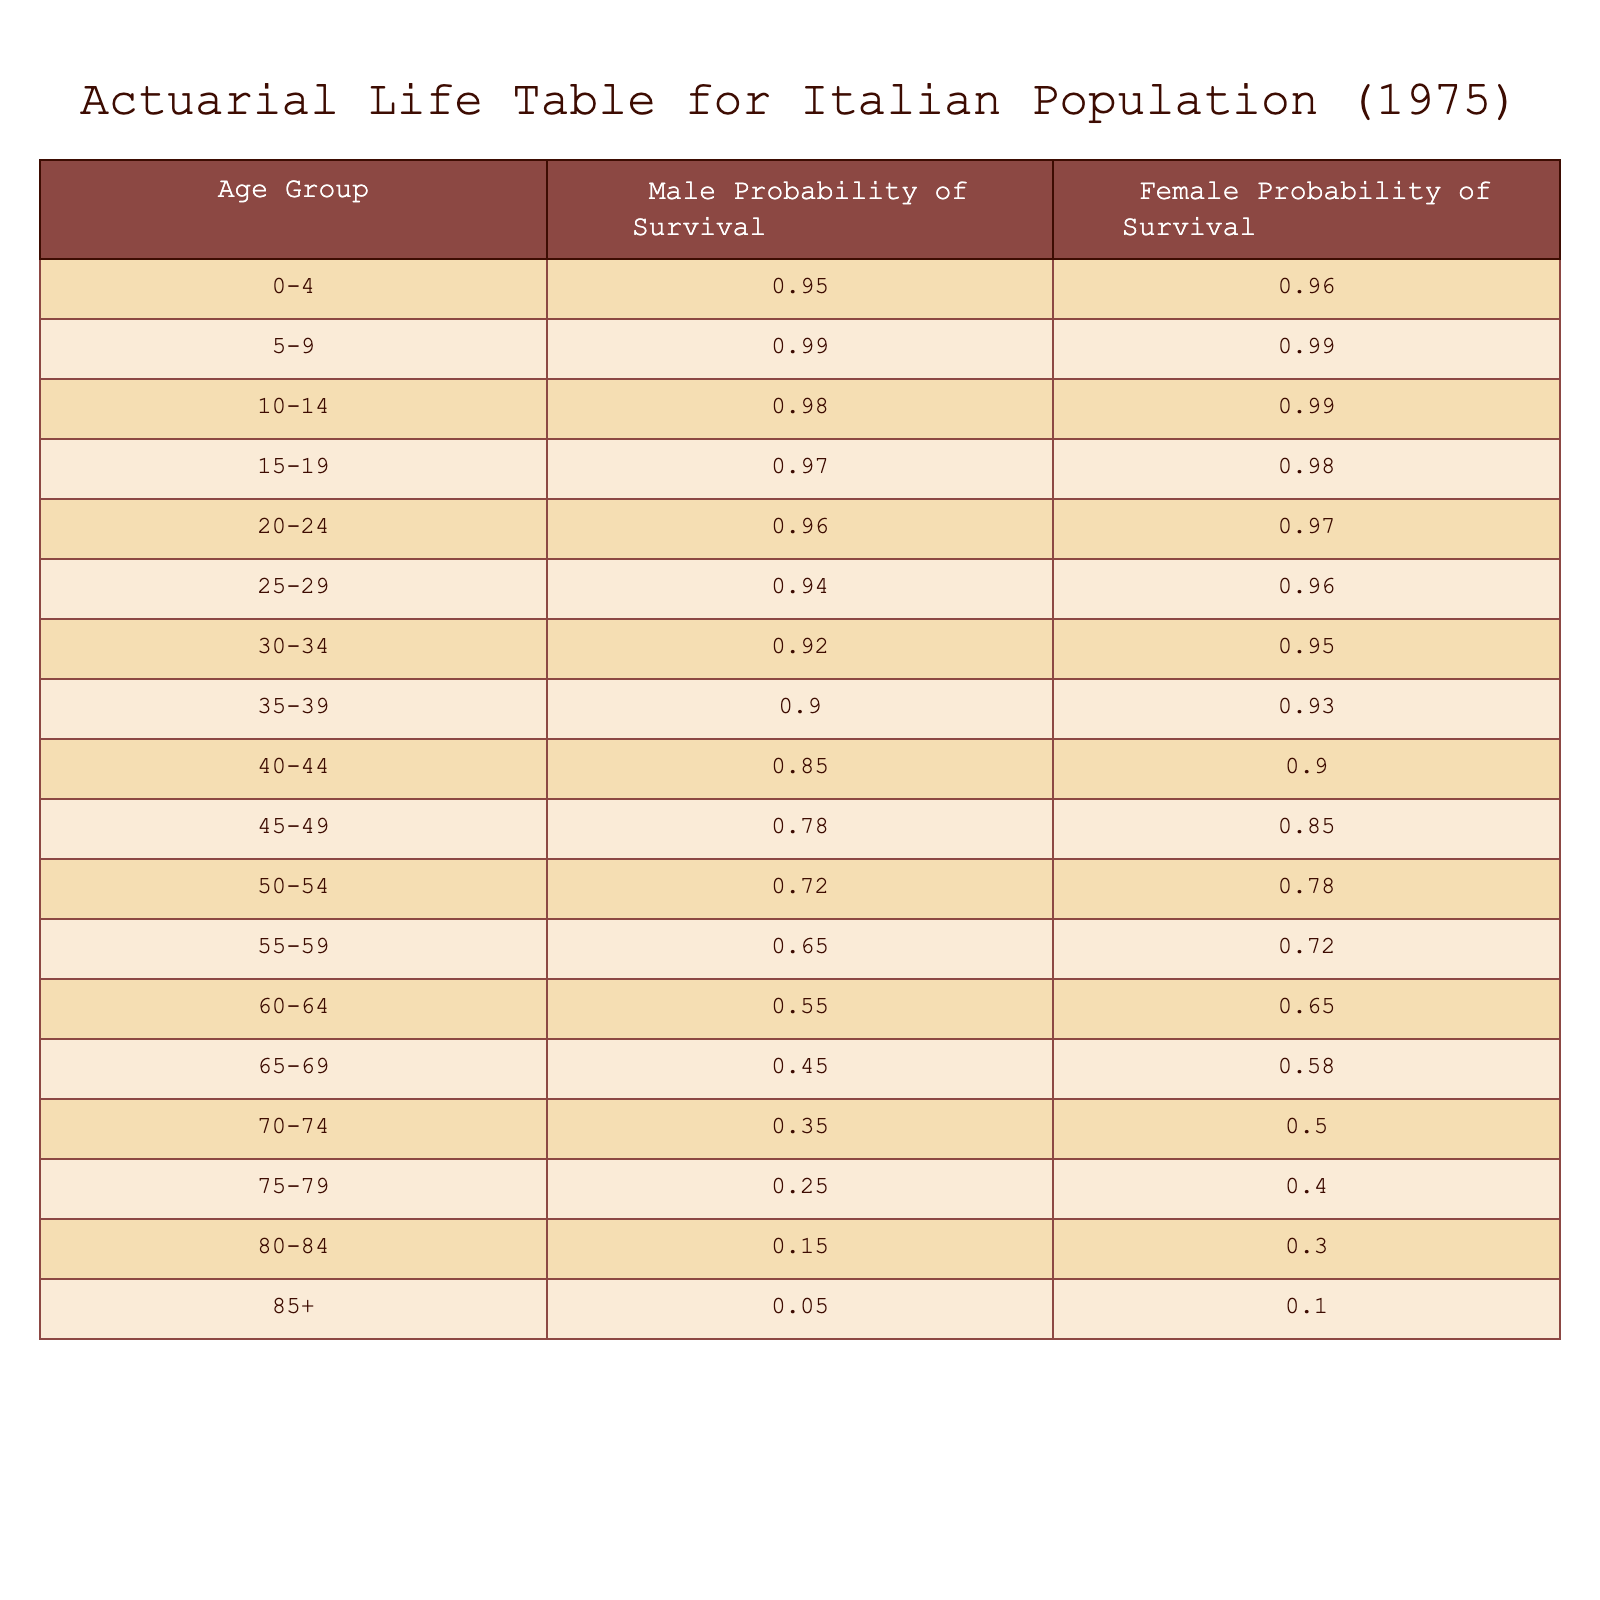What is the probability of survival for males aged 30-34? According to the table, the probability of survival for males aged 30-34 is directly listed as 0.92.
Answer: 0.92 What is the probability of survival for females in the age group 70-74? In the table, the probability of survival for females aged 70-74 is found to be 0.50.
Answer: 0.50 Which age group shows the lowest probability of survival for males? By examining the table, the lowest probability for males comes from the age group 80-84, which is 0.15.
Answer: 0.15 On average, how does female survival probability compare between the age groups 55-59 and 60-64? For females aged 55-59, the survival probability is 0.72; for 60-64, it is 0.65. The average of these two values is (0.72 + 0.65) / 2 = 0.685.
Answer: 0.685 Is the probability of survival greater for females in the age group 45-49 than for males in the same group? Looking at the probabilities, females aged 45-49 have a survival probability of 0.85, while males in the same group have a probability of 0.78. This means females have a higher probability.
Answer: Yes What is the total probability of survival for males across the age groups 0-4 and 5-9? The survival probabilities for males in these groups are 0.95 (0-4) and 0.99 (5-9). Adding these together gives 0.95 + 0.99 = 1.94.
Answer: 1.94 If we compare the probabilities of survival for the age group 75-79, do males or females have a higher survival rate? In the table, males aged 75-79 have a survival probability of 0.25, whereas females in the same age group have 0.40. Hence, females have a higher survival rate.
Answer: Females What percentage of survival for females in the age group 85+ is higher than 0.10? The data shows that the survival probability for females aged 85+ is 0.10. Since the question asks if it is higher than 0.10, and it equals 0.10, it is not higher.
Answer: No What is the difference in the survival probability between males aged 70-74 and females aged 70-74? The probability of survival for males aged 70-74 is 0.35, while for females it is 0.50. The difference is calculated by subtracting: 0.50 - 0.35 = 0.15.
Answer: 0.15 